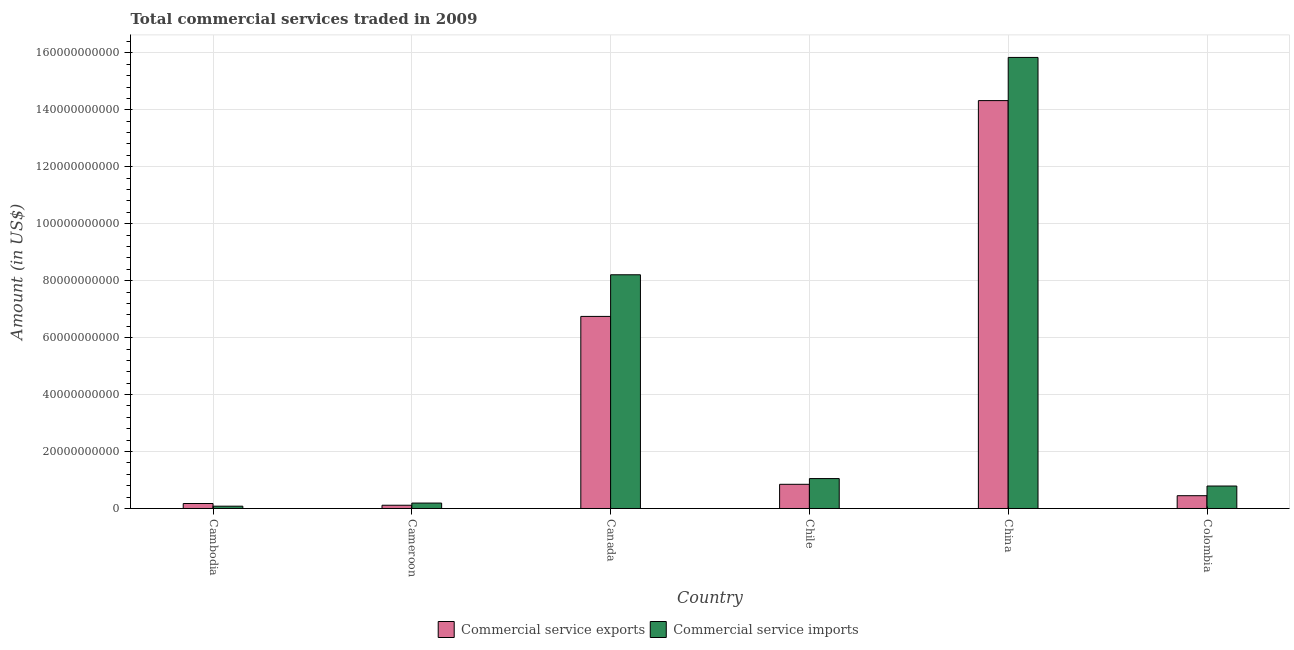How many groups of bars are there?
Provide a short and direct response. 6. Are the number of bars per tick equal to the number of legend labels?
Your answer should be compact. Yes. Are the number of bars on each tick of the X-axis equal?
Your response must be concise. Yes. How many bars are there on the 6th tick from the left?
Offer a very short reply. 2. What is the label of the 3rd group of bars from the left?
Offer a terse response. Canada. What is the amount of commercial service exports in China?
Keep it short and to the point. 1.43e+11. Across all countries, what is the maximum amount of commercial service exports?
Offer a terse response. 1.43e+11. Across all countries, what is the minimum amount of commercial service exports?
Make the answer very short. 1.14e+09. In which country was the amount of commercial service imports maximum?
Make the answer very short. China. In which country was the amount of commercial service imports minimum?
Your answer should be very brief. Cambodia. What is the total amount of commercial service exports in the graph?
Provide a succinct answer. 2.27e+11. What is the difference between the amount of commercial service imports in Chile and that in Colombia?
Your answer should be compact. 2.61e+09. What is the difference between the amount of commercial service imports in Chile and the amount of commercial service exports in Cameroon?
Offer a terse response. 9.36e+09. What is the average amount of commercial service imports per country?
Your answer should be compact. 4.36e+1. What is the difference between the amount of commercial service imports and amount of commercial service exports in China?
Give a very brief answer. 1.52e+1. In how many countries, is the amount of commercial service imports greater than 48000000000 US$?
Offer a terse response. 2. What is the ratio of the amount of commercial service imports in Cambodia to that in Canada?
Provide a short and direct response. 0.01. Is the difference between the amount of commercial service imports in Canada and Chile greater than the difference between the amount of commercial service exports in Canada and Chile?
Offer a very short reply. Yes. What is the difference between the highest and the second highest amount of commercial service imports?
Ensure brevity in your answer.  7.63e+1. What is the difference between the highest and the lowest amount of commercial service imports?
Offer a very short reply. 1.58e+11. In how many countries, is the amount of commercial service exports greater than the average amount of commercial service exports taken over all countries?
Your response must be concise. 2. Is the sum of the amount of commercial service imports in Cameroon and Chile greater than the maximum amount of commercial service exports across all countries?
Offer a very short reply. No. What does the 2nd bar from the left in Cambodia represents?
Keep it short and to the point. Commercial service imports. What does the 2nd bar from the right in Canada represents?
Offer a very short reply. Commercial service exports. Are all the bars in the graph horizontal?
Your answer should be very brief. No. What is the difference between two consecutive major ticks on the Y-axis?
Offer a very short reply. 2.00e+1. How many legend labels are there?
Make the answer very short. 2. How are the legend labels stacked?
Make the answer very short. Horizontal. What is the title of the graph?
Provide a succinct answer. Total commercial services traded in 2009. Does "Quasi money growth" appear as one of the legend labels in the graph?
Your answer should be compact. No. What is the label or title of the Y-axis?
Provide a short and direct response. Amount (in US$). What is the Amount (in US$) in Commercial service exports in Cambodia?
Ensure brevity in your answer.  1.75e+09. What is the Amount (in US$) of Commercial service imports in Cambodia?
Your answer should be very brief. 8.10e+08. What is the Amount (in US$) of Commercial service exports in Cameroon?
Your response must be concise. 1.14e+09. What is the Amount (in US$) in Commercial service imports in Cameroon?
Your response must be concise. 1.90e+09. What is the Amount (in US$) of Commercial service exports in Canada?
Offer a very short reply. 6.74e+1. What is the Amount (in US$) in Commercial service imports in Canada?
Make the answer very short. 8.21e+1. What is the Amount (in US$) in Commercial service exports in Chile?
Ensure brevity in your answer.  8.49e+09. What is the Amount (in US$) of Commercial service imports in Chile?
Your response must be concise. 1.05e+1. What is the Amount (in US$) of Commercial service exports in China?
Your answer should be compact. 1.43e+11. What is the Amount (in US$) in Commercial service imports in China?
Provide a succinct answer. 1.58e+11. What is the Amount (in US$) of Commercial service exports in Colombia?
Ensure brevity in your answer.  4.49e+09. What is the Amount (in US$) in Commercial service imports in Colombia?
Your answer should be compact. 7.89e+09. Across all countries, what is the maximum Amount (in US$) of Commercial service exports?
Your response must be concise. 1.43e+11. Across all countries, what is the maximum Amount (in US$) of Commercial service imports?
Your answer should be compact. 1.58e+11. Across all countries, what is the minimum Amount (in US$) in Commercial service exports?
Provide a short and direct response. 1.14e+09. Across all countries, what is the minimum Amount (in US$) of Commercial service imports?
Provide a short and direct response. 8.10e+08. What is the total Amount (in US$) of Commercial service exports in the graph?
Provide a succinct answer. 2.27e+11. What is the total Amount (in US$) of Commercial service imports in the graph?
Your response must be concise. 2.62e+11. What is the difference between the Amount (in US$) of Commercial service exports in Cambodia and that in Cameroon?
Your answer should be compact. 6.05e+08. What is the difference between the Amount (in US$) in Commercial service imports in Cambodia and that in Cameroon?
Your answer should be very brief. -1.09e+09. What is the difference between the Amount (in US$) of Commercial service exports in Cambodia and that in Canada?
Your answer should be very brief. -6.57e+1. What is the difference between the Amount (in US$) in Commercial service imports in Cambodia and that in Canada?
Your answer should be compact. -8.13e+1. What is the difference between the Amount (in US$) in Commercial service exports in Cambodia and that in Chile?
Give a very brief answer. -6.75e+09. What is the difference between the Amount (in US$) in Commercial service imports in Cambodia and that in Chile?
Your answer should be very brief. -9.69e+09. What is the difference between the Amount (in US$) of Commercial service exports in Cambodia and that in China?
Offer a terse response. -1.41e+11. What is the difference between the Amount (in US$) of Commercial service imports in Cambodia and that in China?
Ensure brevity in your answer.  -1.58e+11. What is the difference between the Amount (in US$) of Commercial service exports in Cambodia and that in Colombia?
Your answer should be compact. -2.75e+09. What is the difference between the Amount (in US$) of Commercial service imports in Cambodia and that in Colombia?
Keep it short and to the point. -7.08e+09. What is the difference between the Amount (in US$) in Commercial service exports in Cameroon and that in Canada?
Keep it short and to the point. -6.63e+1. What is the difference between the Amount (in US$) of Commercial service imports in Cameroon and that in Canada?
Offer a terse response. -8.02e+1. What is the difference between the Amount (in US$) of Commercial service exports in Cameroon and that in Chile?
Provide a short and direct response. -7.35e+09. What is the difference between the Amount (in US$) in Commercial service imports in Cameroon and that in Chile?
Your response must be concise. -8.60e+09. What is the difference between the Amount (in US$) of Commercial service exports in Cameroon and that in China?
Ensure brevity in your answer.  -1.42e+11. What is the difference between the Amount (in US$) in Commercial service imports in Cameroon and that in China?
Offer a very short reply. -1.56e+11. What is the difference between the Amount (in US$) in Commercial service exports in Cameroon and that in Colombia?
Keep it short and to the point. -3.35e+09. What is the difference between the Amount (in US$) in Commercial service imports in Cameroon and that in Colombia?
Your response must be concise. -5.99e+09. What is the difference between the Amount (in US$) in Commercial service exports in Canada and that in Chile?
Provide a short and direct response. 5.90e+1. What is the difference between the Amount (in US$) of Commercial service imports in Canada and that in Chile?
Keep it short and to the point. 7.16e+1. What is the difference between the Amount (in US$) in Commercial service exports in Canada and that in China?
Offer a very short reply. -7.58e+1. What is the difference between the Amount (in US$) in Commercial service imports in Canada and that in China?
Provide a short and direct response. -7.63e+1. What is the difference between the Amount (in US$) of Commercial service exports in Canada and that in Colombia?
Give a very brief answer. 6.30e+1. What is the difference between the Amount (in US$) of Commercial service imports in Canada and that in Colombia?
Provide a succinct answer. 7.42e+1. What is the difference between the Amount (in US$) of Commercial service exports in Chile and that in China?
Give a very brief answer. -1.35e+11. What is the difference between the Amount (in US$) of Commercial service imports in Chile and that in China?
Make the answer very short. -1.48e+11. What is the difference between the Amount (in US$) of Commercial service exports in Chile and that in Colombia?
Your answer should be compact. 4.00e+09. What is the difference between the Amount (in US$) of Commercial service imports in Chile and that in Colombia?
Provide a succinct answer. 2.61e+09. What is the difference between the Amount (in US$) in Commercial service exports in China and that in Colombia?
Offer a very short reply. 1.39e+11. What is the difference between the Amount (in US$) in Commercial service imports in China and that in Colombia?
Give a very brief answer. 1.51e+11. What is the difference between the Amount (in US$) in Commercial service exports in Cambodia and the Amount (in US$) in Commercial service imports in Cameroon?
Provide a succinct answer. -1.55e+08. What is the difference between the Amount (in US$) in Commercial service exports in Cambodia and the Amount (in US$) in Commercial service imports in Canada?
Your answer should be very brief. -8.03e+1. What is the difference between the Amount (in US$) in Commercial service exports in Cambodia and the Amount (in US$) in Commercial service imports in Chile?
Offer a very short reply. -8.76e+09. What is the difference between the Amount (in US$) in Commercial service exports in Cambodia and the Amount (in US$) in Commercial service imports in China?
Provide a succinct answer. -1.57e+11. What is the difference between the Amount (in US$) in Commercial service exports in Cambodia and the Amount (in US$) in Commercial service imports in Colombia?
Provide a short and direct response. -6.14e+09. What is the difference between the Amount (in US$) of Commercial service exports in Cameroon and the Amount (in US$) of Commercial service imports in Canada?
Your answer should be compact. -8.09e+1. What is the difference between the Amount (in US$) in Commercial service exports in Cameroon and the Amount (in US$) in Commercial service imports in Chile?
Provide a short and direct response. -9.36e+09. What is the difference between the Amount (in US$) of Commercial service exports in Cameroon and the Amount (in US$) of Commercial service imports in China?
Provide a succinct answer. -1.57e+11. What is the difference between the Amount (in US$) in Commercial service exports in Cameroon and the Amount (in US$) in Commercial service imports in Colombia?
Provide a short and direct response. -6.75e+09. What is the difference between the Amount (in US$) in Commercial service exports in Canada and the Amount (in US$) in Commercial service imports in Chile?
Provide a short and direct response. 5.69e+1. What is the difference between the Amount (in US$) of Commercial service exports in Canada and the Amount (in US$) of Commercial service imports in China?
Give a very brief answer. -9.09e+1. What is the difference between the Amount (in US$) of Commercial service exports in Canada and the Amount (in US$) of Commercial service imports in Colombia?
Your answer should be very brief. 5.96e+1. What is the difference between the Amount (in US$) of Commercial service exports in Chile and the Amount (in US$) of Commercial service imports in China?
Make the answer very short. -1.50e+11. What is the difference between the Amount (in US$) of Commercial service exports in Chile and the Amount (in US$) of Commercial service imports in Colombia?
Give a very brief answer. 6.04e+08. What is the difference between the Amount (in US$) of Commercial service exports in China and the Amount (in US$) of Commercial service imports in Colombia?
Your answer should be very brief. 1.35e+11. What is the average Amount (in US$) in Commercial service exports per country?
Offer a very short reply. 3.78e+1. What is the average Amount (in US$) in Commercial service imports per country?
Your answer should be very brief. 4.36e+1. What is the difference between the Amount (in US$) in Commercial service exports and Amount (in US$) in Commercial service imports in Cambodia?
Ensure brevity in your answer.  9.37e+08. What is the difference between the Amount (in US$) in Commercial service exports and Amount (in US$) in Commercial service imports in Cameroon?
Offer a very short reply. -7.61e+08. What is the difference between the Amount (in US$) of Commercial service exports and Amount (in US$) of Commercial service imports in Canada?
Offer a very short reply. -1.46e+1. What is the difference between the Amount (in US$) in Commercial service exports and Amount (in US$) in Commercial service imports in Chile?
Provide a succinct answer. -2.01e+09. What is the difference between the Amount (in US$) of Commercial service exports and Amount (in US$) of Commercial service imports in China?
Keep it short and to the point. -1.52e+1. What is the difference between the Amount (in US$) of Commercial service exports and Amount (in US$) of Commercial service imports in Colombia?
Offer a very short reply. -3.39e+09. What is the ratio of the Amount (in US$) of Commercial service exports in Cambodia to that in Cameroon?
Keep it short and to the point. 1.53. What is the ratio of the Amount (in US$) in Commercial service imports in Cambodia to that in Cameroon?
Your response must be concise. 0.43. What is the ratio of the Amount (in US$) in Commercial service exports in Cambodia to that in Canada?
Your answer should be very brief. 0.03. What is the ratio of the Amount (in US$) in Commercial service imports in Cambodia to that in Canada?
Ensure brevity in your answer.  0.01. What is the ratio of the Amount (in US$) of Commercial service exports in Cambodia to that in Chile?
Offer a terse response. 0.21. What is the ratio of the Amount (in US$) of Commercial service imports in Cambodia to that in Chile?
Your answer should be very brief. 0.08. What is the ratio of the Amount (in US$) of Commercial service exports in Cambodia to that in China?
Ensure brevity in your answer.  0.01. What is the ratio of the Amount (in US$) of Commercial service imports in Cambodia to that in China?
Offer a terse response. 0.01. What is the ratio of the Amount (in US$) of Commercial service exports in Cambodia to that in Colombia?
Your answer should be very brief. 0.39. What is the ratio of the Amount (in US$) of Commercial service imports in Cambodia to that in Colombia?
Provide a succinct answer. 0.1. What is the ratio of the Amount (in US$) in Commercial service exports in Cameroon to that in Canada?
Your response must be concise. 0.02. What is the ratio of the Amount (in US$) of Commercial service imports in Cameroon to that in Canada?
Your answer should be compact. 0.02. What is the ratio of the Amount (in US$) of Commercial service exports in Cameroon to that in Chile?
Offer a terse response. 0.13. What is the ratio of the Amount (in US$) of Commercial service imports in Cameroon to that in Chile?
Give a very brief answer. 0.18. What is the ratio of the Amount (in US$) in Commercial service exports in Cameroon to that in China?
Give a very brief answer. 0.01. What is the ratio of the Amount (in US$) of Commercial service imports in Cameroon to that in China?
Your answer should be compact. 0.01. What is the ratio of the Amount (in US$) in Commercial service exports in Cameroon to that in Colombia?
Your response must be concise. 0.25. What is the ratio of the Amount (in US$) in Commercial service imports in Cameroon to that in Colombia?
Ensure brevity in your answer.  0.24. What is the ratio of the Amount (in US$) in Commercial service exports in Canada to that in Chile?
Your answer should be very brief. 7.94. What is the ratio of the Amount (in US$) of Commercial service imports in Canada to that in Chile?
Your answer should be very brief. 7.81. What is the ratio of the Amount (in US$) in Commercial service exports in Canada to that in China?
Your answer should be compact. 0.47. What is the ratio of the Amount (in US$) of Commercial service imports in Canada to that in China?
Your answer should be compact. 0.52. What is the ratio of the Amount (in US$) of Commercial service exports in Canada to that in Colombia?
Provide a succinct answer. 15.01. What is the ratio of the Amount (in US$) in Commercial service imports in Canada to that in Colombia?
Offer a terse response. 10.4. What is the ratio of the Amount (in US$) in Commercial service exports in Chile to that in China?
Offer a very short reply. 0.06. What is the ratio of the Amount (in US$) of Commercial service imports in Chile to that in China?
Offer a very short reply. 0.07. What is the ratio of the Amount (in US$) of Commercial service exports in Chile to that in Colombia?
Offer a terse response. 1.89. What is the ratio of the Amount (in US$) of Commercial service imports in Chile to that in Colombia?
Ensure brevity in your answer.  1.33. What is the ratio of the Amount (in US$) in Commercial service exports in China to that in Colombia?
Ensure brevity in your answer.  31.87. What is the ratio of the Amount (in US$) in Commercial service imports in China to that in Colombia?
Give a very brief answer. 20.08. What is the difference between the highest and the second highest Amount (in US$) of Commercial service exports?
Your response must be concise. 7.58e+1. What is the difference between the highest and the second highest Amount (in US$) in Commercial service imports?
Make the answer very short. 7.63e+1. What is the difference between the highest and the lowest Amount (in US$) in Commercial service exports?
Ensure brevity in your answer.  1.42e+11. What is the difference between the highest and the lowest Amount (in US$) in Commercial service imports?
Make the answer very short. 1.58e+11. 